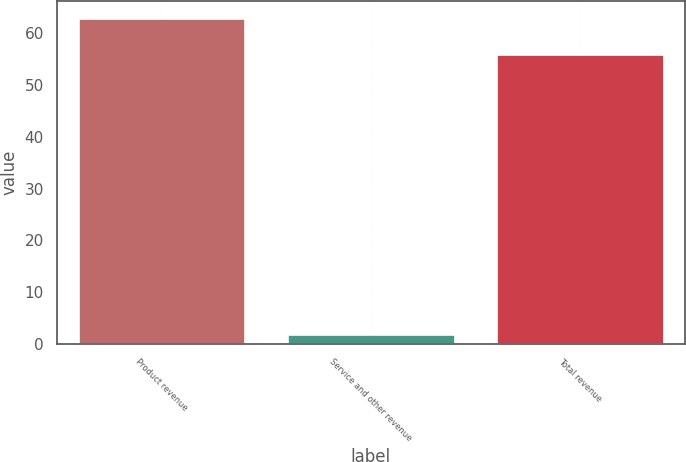<chart> <loc_0><loc_0><loc_500><loc_500><bar_chart><fcel>Product revenue<fcel>Service and other revenue<fcel>Total revenue<nl><fcel>63<fcel>2<fcel>56<nl></chart> 